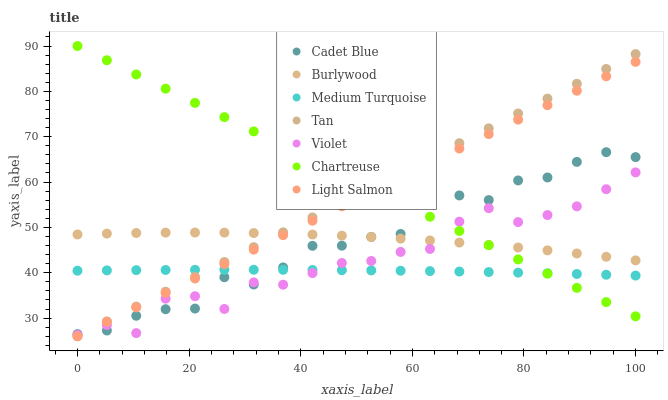Does Medium Turquoise have the minimum area under the curve?
Answer yes or no. Yes. Does Chartreuse have the maximum area under the curve?
Answer yes or no. Yes. Does Cadet Blue have the minimum area under the curve?
Answer yes or no. No. Does Cadet Blue have the maximum area under the curve?
Answer yes or no. No. Is Tan the smoothest?
Answer yes or no. Yes. Is Violet the roughest?
Answer yes or no. Yes. Is Cadet Blue the smoothest?
Answer yes or no. No. Is Cadet Blue the roughest?
Answer yes or no. No. Does Light Salmon have the lowest value?
Answer yes or no. Yes. Does Cadet Blue have the lowest value?
Answer yes or no. No. Does Chartreuse have the highest value?
Answer yes or no. Yes. Does Cadet Blue have the highest value?
Answer yes or no. No. Is Medium Turquoise less than Burlywood?
Answer yes or no. Yes. Is Burlywood greater than Medium Turquoise?
Answer yes or no. Yes. Does Medium Turquoise intersect Chartreuse?
Answer yes or no. Yes. Is Medium Turquoise less than Chartreuse?
Answer yes or no. No. Is Medium Turquoise greater than Chartreuse?
Answer yes or no. No. Does Medium Turquoise intersect Burlywood?
Answer yes or no. No. 